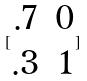Convert formula to latex. <formula><loc_0><loc_0><loc_500><loc_500>[ \begin{matrix} . 7 & 0 \\ . 3 & 1 \end{matrix} ]</formula> 